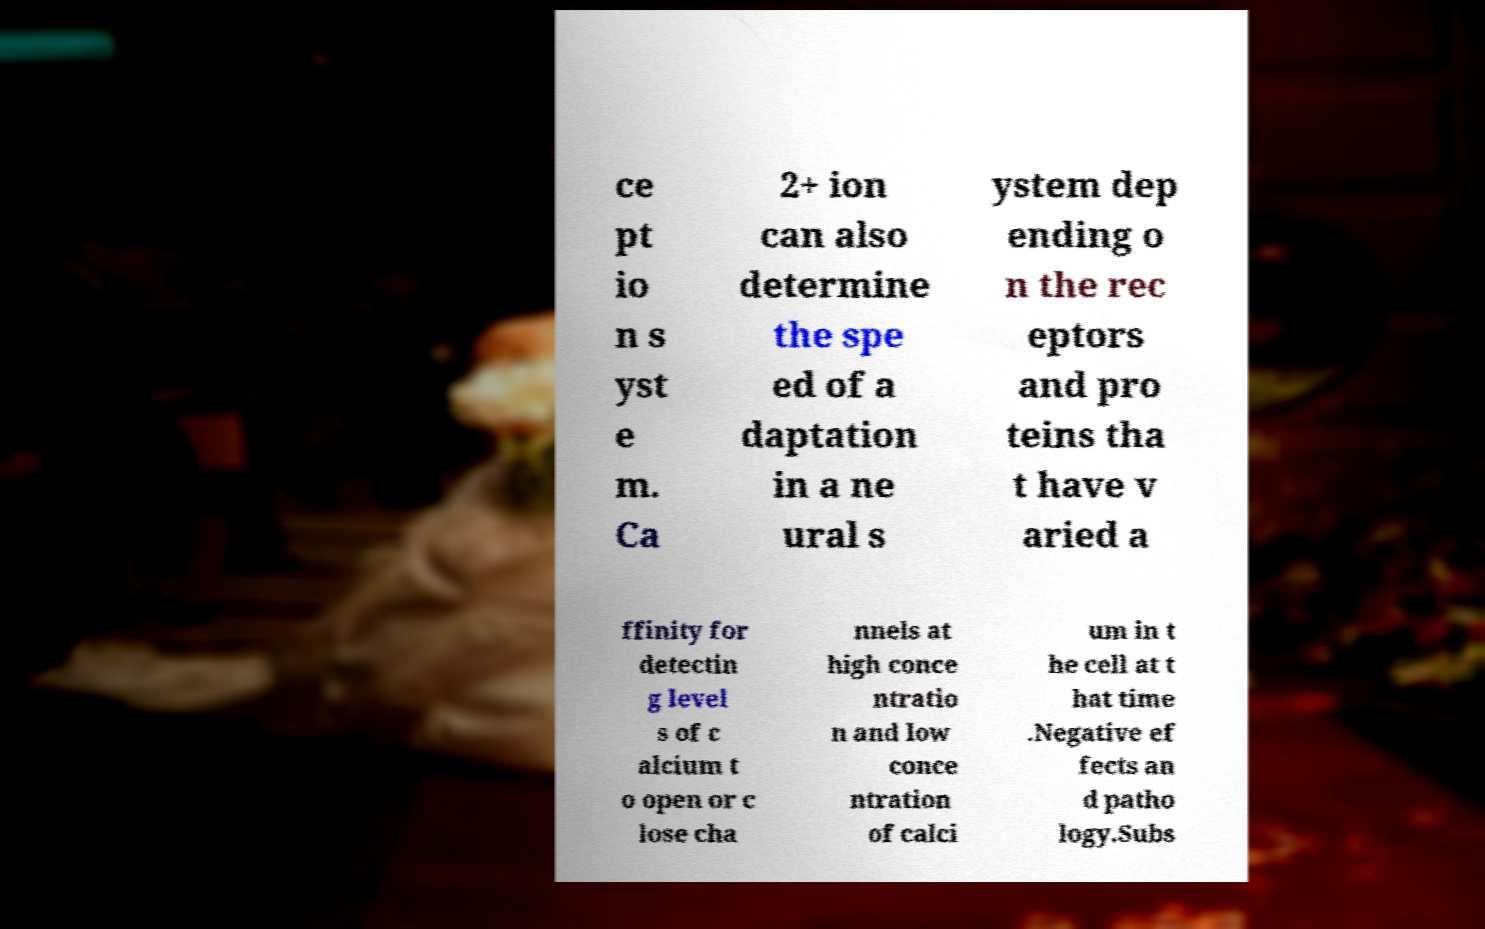Could you assist in decoding the text presented in this image and type it out clearly? ce pt io n s yst e m. Ca 2+ ion can also determine the spe ed of a daptation in a ne ural s ystem dep ending o n the rec eptors and pro teins tha t have v aried a ffinity for detectin g level s of c alcium t o open or c lose cha nnels at high conce ntratio n and low conce ntration of calci um in t he cell at t hat time .Negative ef fects an d patho logy.Subs 